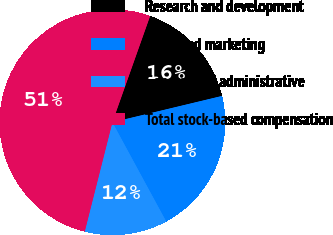Convert chart. <chart><loc_0><loc_0><loc_500><loc_500><pie_chart><fcel>Research and development<fcel>Sales and marketing<fcel>General and administrative<fcel>Total stock-based compensation<nl><fcel>15.82%<fcel>20.84%<fcel>11.86%<fcel>51.49%<nl></chart> 